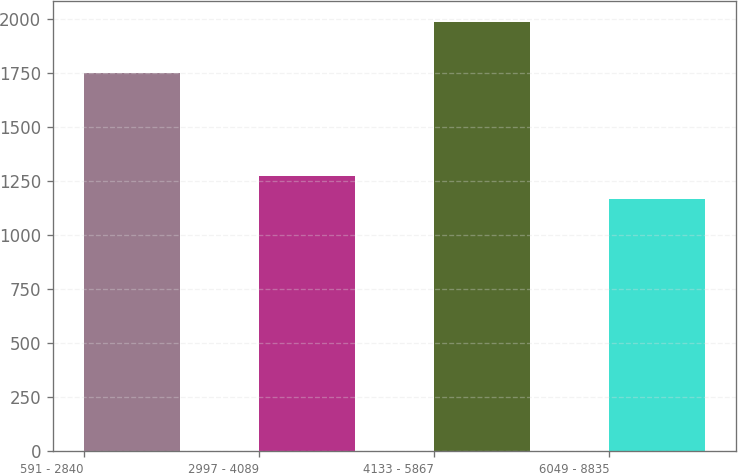Convert chart. <chart><loc_0><loc_0><loc_500><loc_500><bar_chart><fcel>591 - 2840<fcel>2997 - 4089<fcel>4133 - 5867<fcel>6049 - 8835<nl><fcel>1747<fcel>1272<fcel>1983<fcel>1164<nl></chart> 